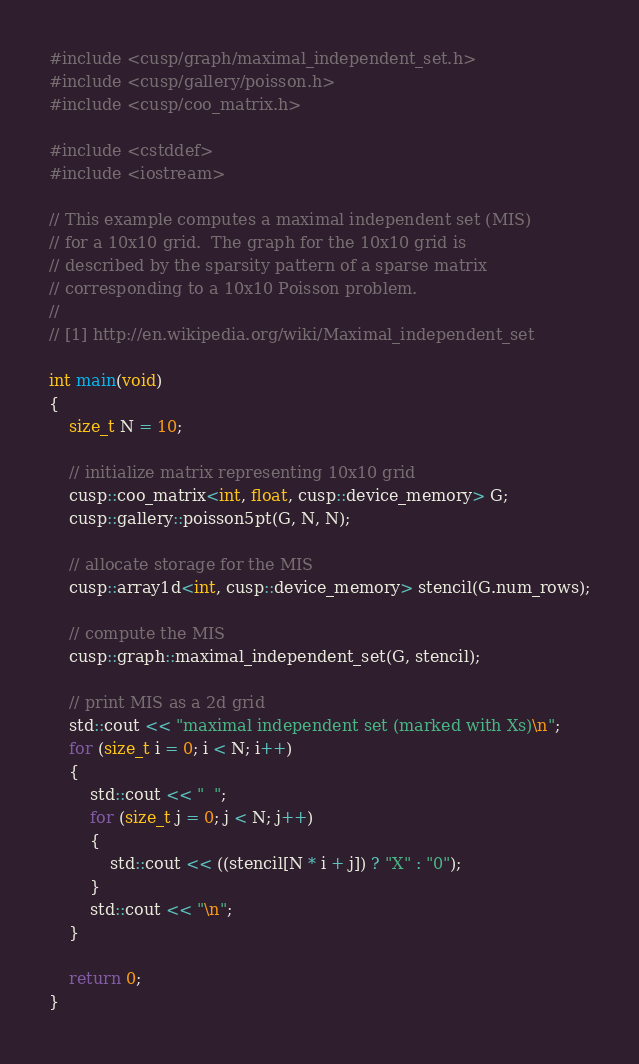<code> <loc_0><loc_0><loc_500><loc_500><_Cuda_>#include <cusp/graph/maximal_independent_set.h>
#include <cusp/gallery/poisson.h>
#include <cusp/coo_matrix.h>

#include <cstddef>
#include <iostream>

// This example computes a maximal independent set (MIS)
// for a 10x10 grid.  The graph for the 10x10 grid is
// described by the sparsity pattern of a sparse matrix
// corresponding to a 10x10 Poisson problem.
//
// [1] http://en.wikipedia.org/wiki/Maximal_independent_set

int main(void)
{
    size_t N = 10;

    // initialize matrix representing 10x10 grid
    cusp::coo_matrix<int, float, cusp::device_memory> G;
    cusp::gallery::poisson5pt(G, N, N);

    // allocate storage for the MIS
    cusp::array1d<int, cusp::device_memory> stencil(G.num_rows);

    // compute the MIS
    cusp::graph::maximal_independent_set(G, stencil);

    // print MIS as a 2d grid
    std::cout << "maximal independent set (marked with Xs)\n";
    for (size_t i = 0; i < N; i++)
    {
        std::cout << "  ";
        for (size_t j = 0; j < N; j++)
        {
            std::cout << ((stencil[N * i + j]) ? "X" : "0");
        }
        std::cout << "\n";
    }

    return 0;
}

</code> 